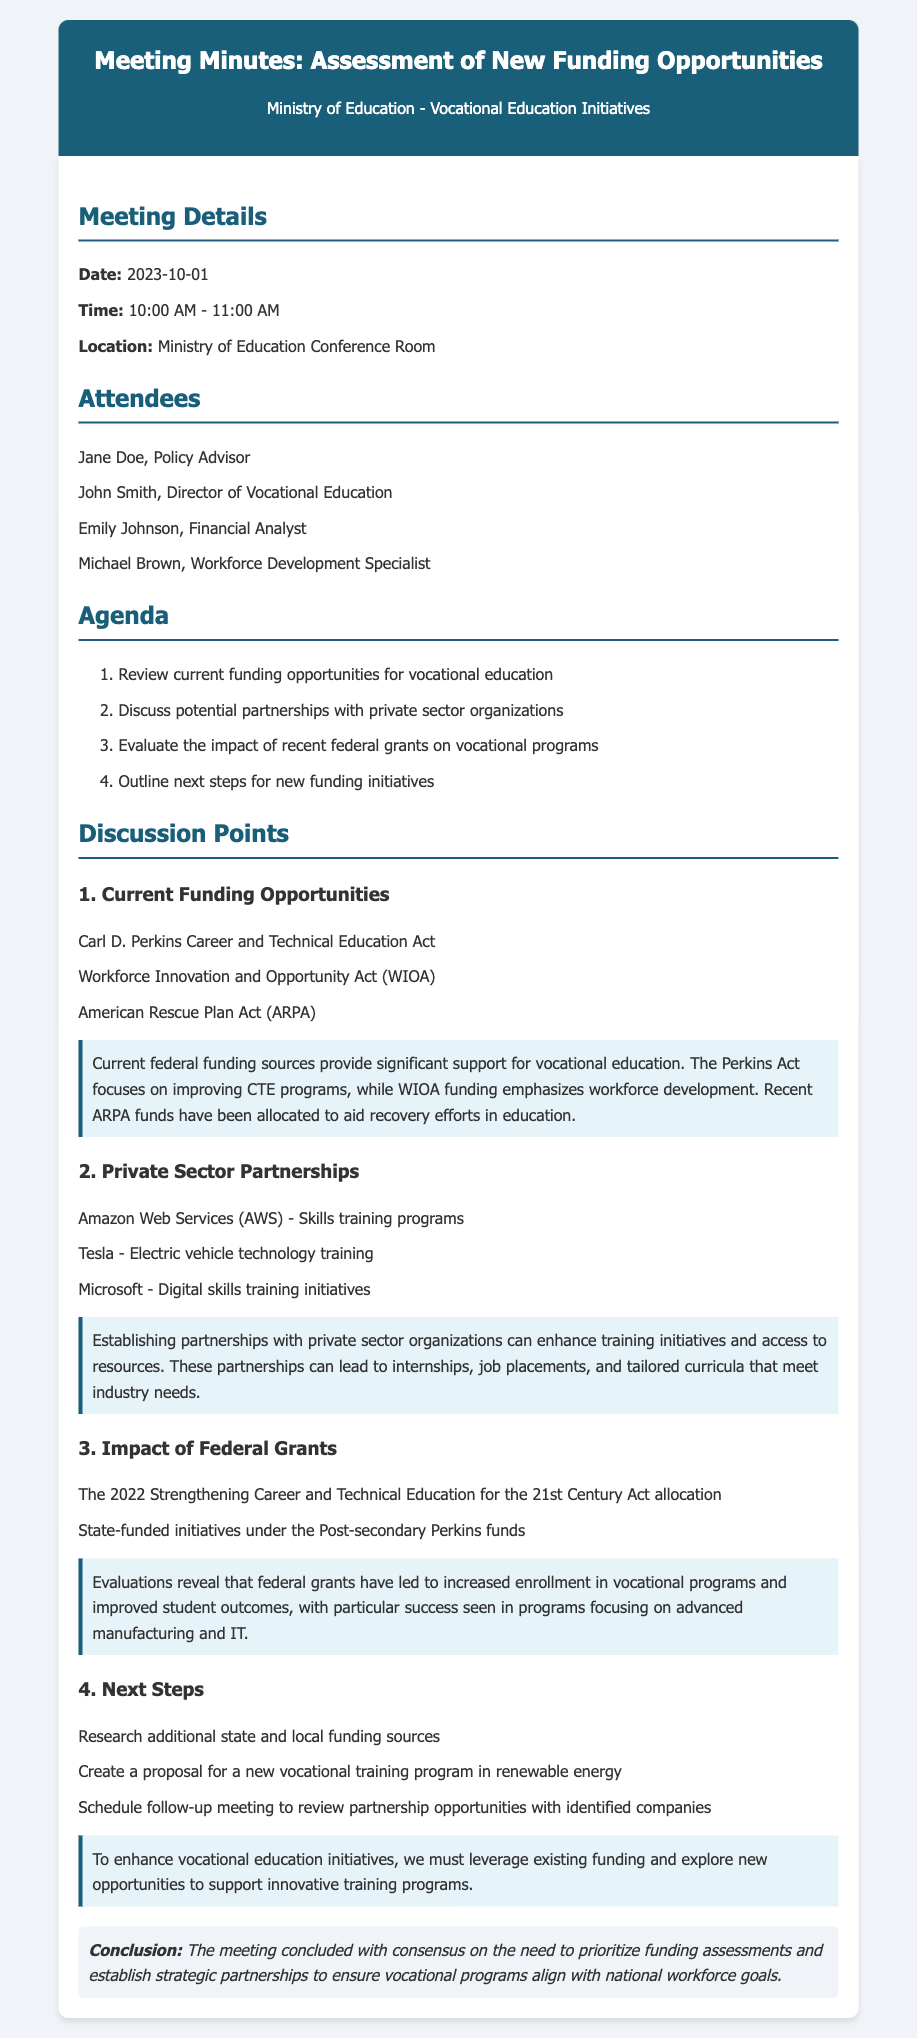what is the date of the meeting? The date of the meeting is listed in the document under Meeting Details.
Answer: 2023-10-01 who is the Director of Vocational Education? The name of the Director of Vocational Education is mentioned in the Attendees section.
Answer: John Smith what is one of the federal grants evaluated in the discussions? A specific federal grant discussed is noted under the Impact of Federal Grants section.
Answer: Strengthening Career and Technical Education for the 21st Century Act what is one potential partnership mentioned? A potential partnership with a private sector organization is highlighted under the Private Sector Partnerships section.
Answer: Amazon Web Services (AWS) how long was the meeting scheduled for? The duration of the meeting is described in the Meeting Details section.
Answer: 1 hour what initiative is proposed in the next steps? A proposed initiative is outlined under the Next Steps section.
Answer: new vocational training program in renewable energy what was the main conclusion of the meeting? The conclusion summarizes the essential agreements made during the meeting.
Answer: prioritize funding assessments which act focuses on improving CTE programs? This act is specifically identified in the Current Funding Opportunities section.
Answer: Carl D. Perkins Career and Technical Education Act 